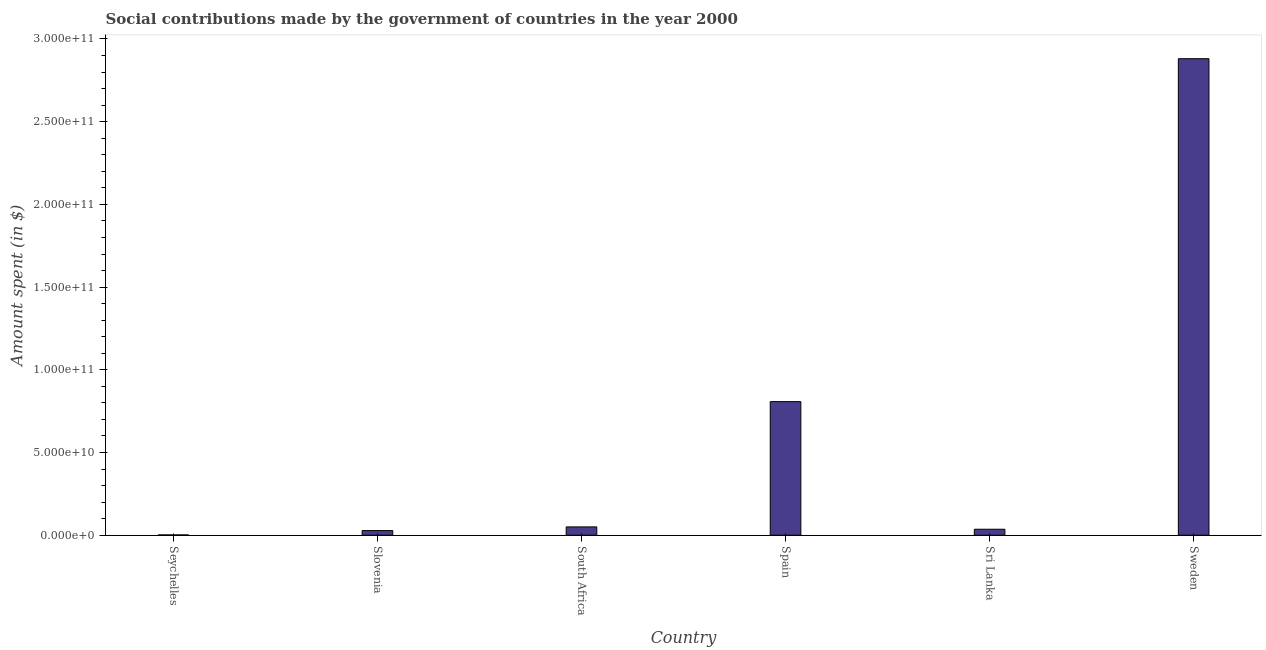Does the graph contain any zero values?
Give a very brief answer. No. Does the graph contain grids?
Keep it short and to the point. No. What is the title of the graph?
Make the answer very short. Social contributions made by the government of countries in the year 2000. What is the label or title of the X-axis?
Your answer should be compact. Country. What is the label or title of the Y-axis?
Your answer should be very brief. Amount spent (in $). What is the amount spent in making social contributions in South Africa?
Make the answer very short. 5.04e+09. Across all countries, what is the maximum amount spent in making social contributions?
Your response must be concise. 2.88e+11. Across all countries, what is the minimum amount spent in making social contributions?
Provide a succinct answer. 1.94e+08. In which country was the amount spent in making social contributions minimum?
Your answer should be very brief. Seychelles. What is the sum of the amount spent in making social contributions?
Keep it short and to the point. 3.81e+11. What is the difference between the amount spent in making social contributions in Spain and Sweden?
Offer a terse response. -2.07e+11. What is the average amount spent in making social contributions per country?
Your response must be concise. 6.34e+1. What is the median amount spent in making social contributions?
Ensure brevity in your answer.  4.33e+09. In how many countries, is the amount spent in making social contributions greater than 250000000000 $?
Make the answer very short. 1. What is the ratio of the amount spent in making social contributions in Slovenia to that in Sri Lanka?
Offer a very short reply. 0.78. Is the difference between the amount spent in making social contributions in Slovenia and Sri Lanka greater than the difference between any two countries?
Provide a short and direct response. No. What is the difference between the highest and the second highest amount spent in making social contributions?
Your answer should be very brief. 2.07e+11. What is the difference between the highest and the lowest amount spent in making social contributions?
Your answer should be very brief. 2.88e+11. In how many countries, is the amount spent in making social contributions greater than the average amount spent in making social contributions taken over all countries?
Your answer should be very brief. 2. How many countries are there in the graph?
Keep it short and to the point. 6. Are the values on the major ticks of Y-axis written in scientific E-notation?
Keep it short and to the point. Yes. What is the Amount spent (in $) of Seychelles?
Ensure brevity in your answer.  1.94e+08. What is the Amount spent (in $) in Slovenia?
Make the answer very short. 2.81e+09. What is the Amount spent (in $) in South Africa?
Offer a very short reply. 5.04e+09. What is the Amount spent (in $) of Spain?
Your answer should be compact. 8.08e+1. What is the Amount spent (in $) of Sri Lanka?
Keep it short and to the point. 3.62e+09. What is the Amount spent (in $) in Sweden?
Offer a terse response. 2.88e+11. What is the difference between the Amount spent (in $) in Seychelles and Slovenia?
Ensure brevity in your answer.  -2.61e+09. What is the difference between the Amount spent (in $) in Seychelles and South Africa?
Your answer should be compact. -4.85e+09. What is the difference between the Amount spent (in $) in Seychelles and Spain?
Give a very brief answer. -8.06e+1. What is the difference between the Amount spent (in $) in Seychelles and Sri Lanka?
Provide a succinct answer. -3.43e+09. What is the difference between the Amount spent (in $) in Seychelles and Sweden?
Provide a succinct answer. -2.88e+11. What is the difference between the Amount spent (in $) in Slovenia and South Africa?
Give a very brief answer. -2.23e+09. What is the difference between the Amount spent (in $) in Slovenia and Spain?
Your response must be concise. -7.80e+1. What is the difference between the Amount spent (in $) in Slovenia and Sri Lanka?
Provide a short and direct response. -8.11e+08. What is the difference between the Amount spent (in $) in Slovenia and Sweden?
Offer a terse response. -2.85e+11. What is the difference between the Amount spent (in $) in South Africa and Spain?
Keep it short and to the point. -7.57e+1. What is the difference between the Amount spent (in $) in South Africa and Sri Lanka?
Give a very brief answer. 1.42e+09. What is the difference between the Amount spent (in $) in South Africa and Sweden?
Keep it short and to the point. -2.83e+11. What is the difference between the Amount spent (in $) in Spain and Sri Lanka?
Give a very brief answer. 7.72e+1. What is the difference between the Amount spent (in $) in Spain and Sweden?
Your answer should be very brief. -2.07e+11. What is the difference between the Amount spent (in $) in Sri Lanka and Sweden?
Your response must be concise. -2.84e+11. What is the ratio of the Amount spent (in $) in Seychelles to that in Slovenia?
Offer a very short reply. 0.07. What is the ratio of the Amount spent (in $) in Seychelles to that in South Africa?
Offer a very short reply. 0.04. What is the ratio of the Amount spent (in $) in Seychelles to that in Spain?
Provide a short and direct response. 0. What is the ratio of the Amount spent (in $) in Seychelles to that in Sri Lanka?
Keep it short and to the point. 0.05. What is the ratio of the Amount spent (in $) in Seychelles to that in Sweden?
Ensure brevity in your answer.  0. What is the ratio of the Amount spent (in $) in Slovenia to that in South Africa?
Make the answer very short. 0.56. What is the ratio of the Amount spent (in $) in Slovenia to that in Spain?
Ensure brevity in your answer.  0.04. What is the ratio of the Amount spent (in $) in Slovenia to that in Sri Lanka?
Offer a very short reply. 0.78. What is the ratio of the Amount spent (in $) in South Africa to that in Spain?
Give a very brief answer. 0.06. What is the ratio of the Amount spent (in $) in South Africa to that in Sri Lanka?
Your response must be concise. 1.39. What is the ratio of the Amount spent (in $) in South Africa to that in Sweden?
Offer a very short reply. 0.02. What is the ratio of the Amount spent (in $) in Spain to that in Sri Lanka?
Provide a short and direct response. 22.32. What is the ratio of the Amount spent (in $) in Spain to that in Sweden?
Keep it short and to the point. 0.28. What is the ratio of the Amount spent (in $) in Sri Lanka to that in Sweden?
Provide a short and direct response. 0.01. 